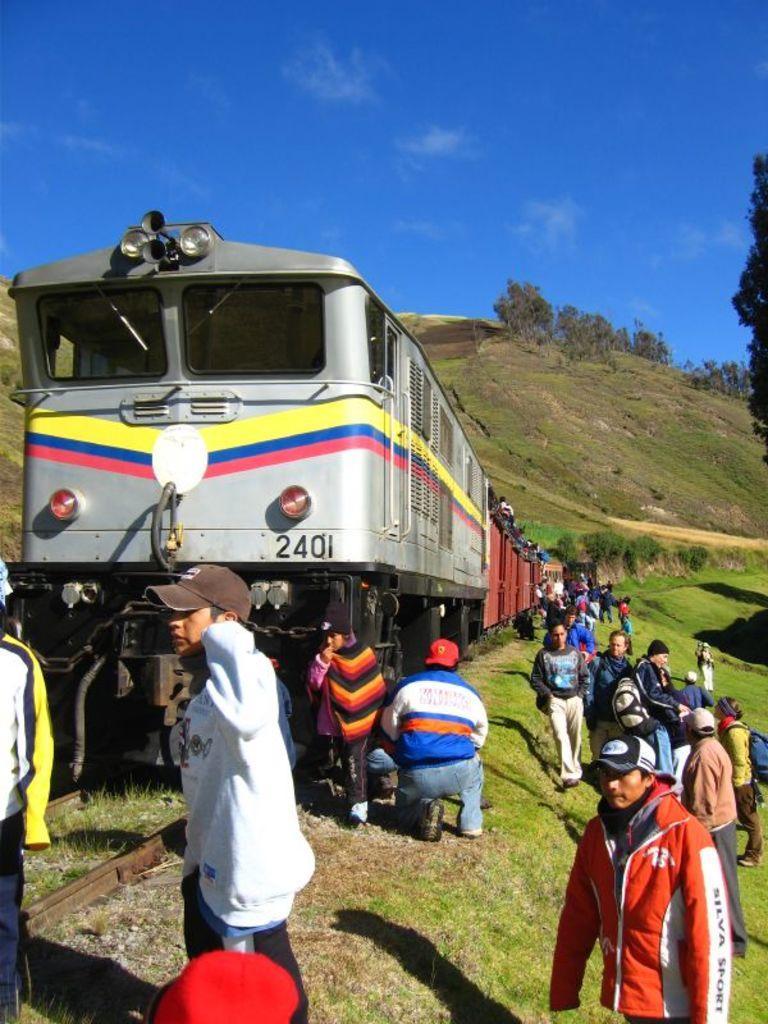Could you give a brief overview of what you see in this image? In this image we can see the mountains, one train on the track, some people in the train, some people are standing, one man in kneeling position near the train, some people are walking, some people wearing bags, some trees, bushes, plants and grass on the ground. At the top there is the sky. 